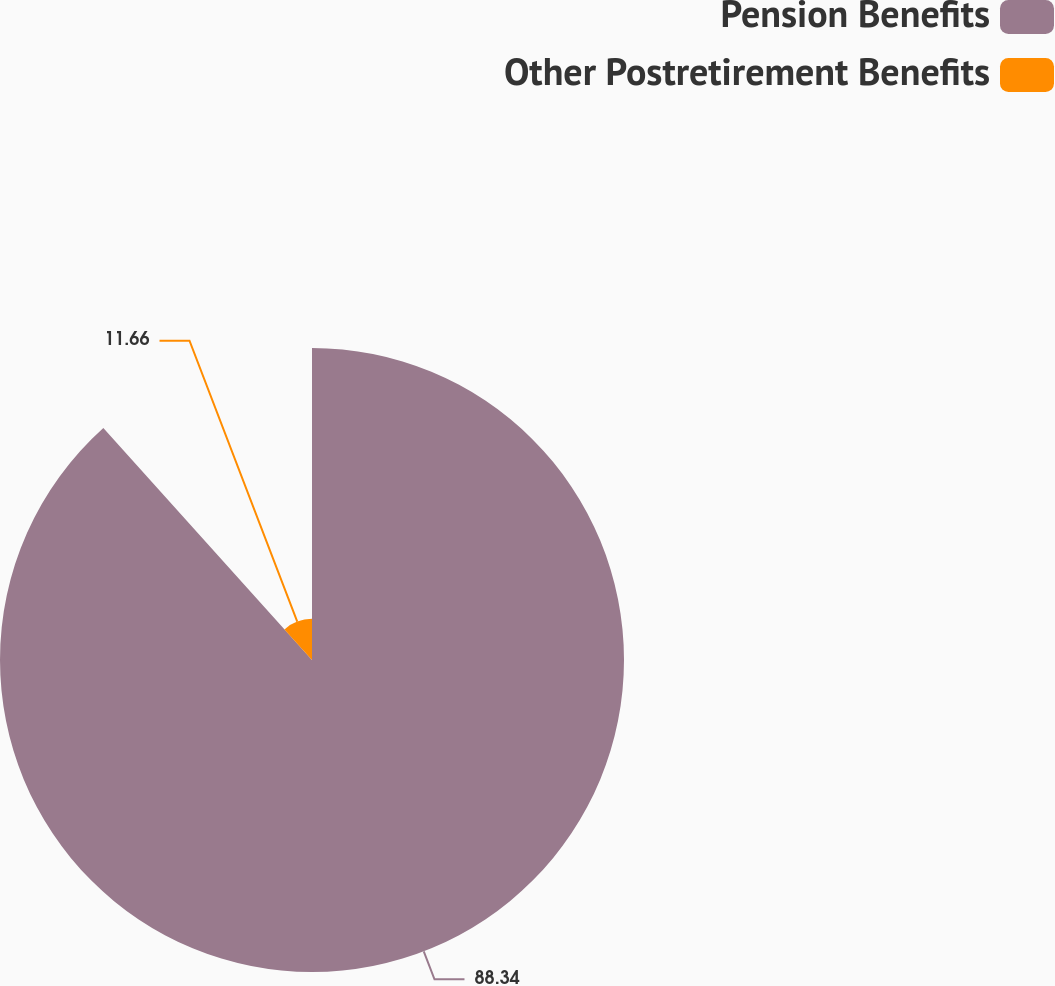<chart> <loc_0><loc_0><loc_500><loc_500><pie_chart><fcel>Pension Benefits<fcel>Other Postretirement Benefits<nl><fcel>88.34%<fcel>11.66%<nl></chart> 